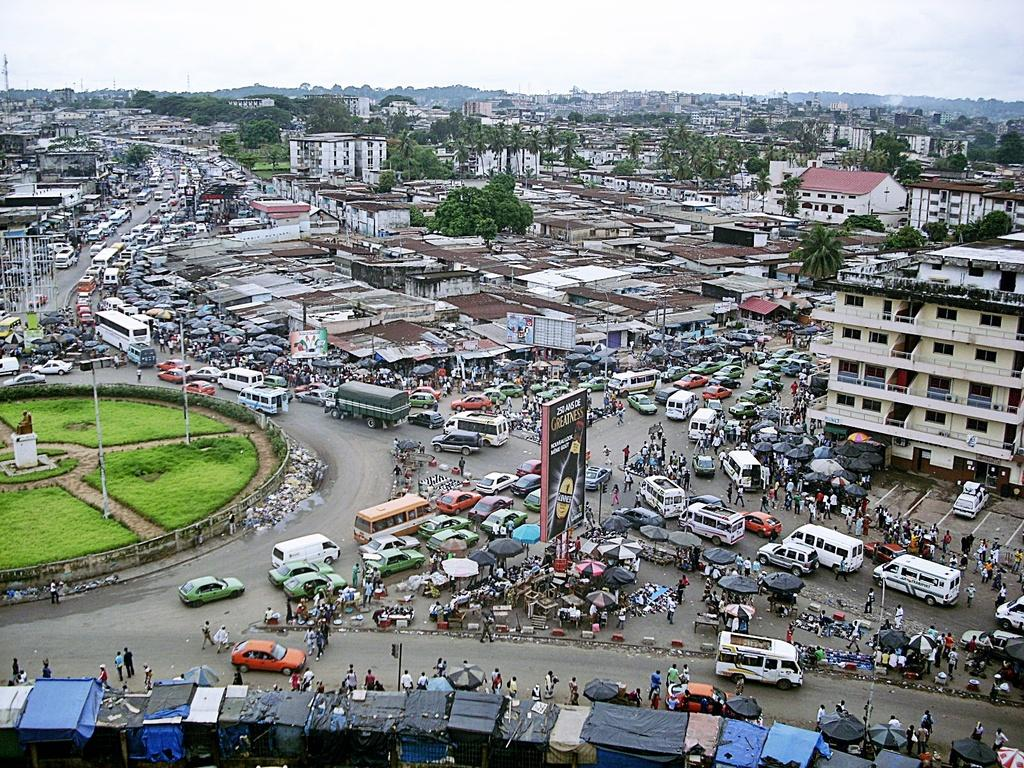What is the main feature of the image? There is a road in the image. What can be seen on the road? There are vehicles on the road. What type of vegetation is present in the image? There is grass on the ground. What other objects can be seen in the image? There are boards in the image. Are there any people in the image? Yes, there are people in the image. What type of structures are visible in the image? There are buildings in the image. What is visible in the background of the image? The sky is visible in the background of the image. How many cacti can be seen growing along the road in the image? There are no cacti visible in the image; it features a road with grass and other elements. 